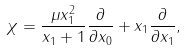Convert formula to latex. <formula><loc_0><loc_0><loc_500><loc_500>\chi = \frac { \mu x _ { 1 } ^ { 2 } } { x _ { 1 } + 1 } \frac { \partial } { \partial x _ { 0 } } + x _ { 1 } \frac { \partial } { \partial x _ { 1 } } ,</formula> 